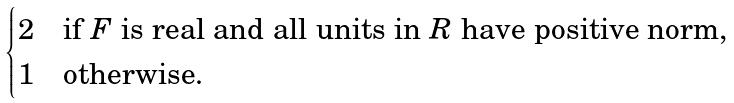Convert formula to latex. <formula><loc_0><loc_0><loc_500><loc_500>\begin{cases} 2 & \text {if $F$ is real and all units in $R$ have positive norm,} \\ 1 & \text {otherwise.} \end{cases}</formula> 